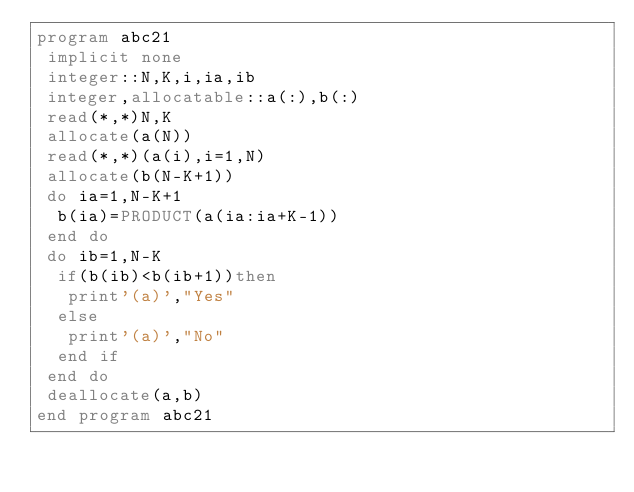<code> <loc_0><loc_0><loc_500><loc_500><_FORTRAN_>program abc21
 implicit none
 integer::N,K,i,ia,ib
 integer,allocatable::a(:),b(:)
 read(*,*)N,K
 allocate(a(N))
 read(*,*)(a(i),i=1,N)
 allocate(b(N-K+1))
 do ia=1,N-K+1
  b(ia)=PRODUCT(a(ia:ia+K-1))
 end do
 do ib=1,N-K
  if(b(ib)<b(ib+1))then
   print'(a)',"Yes"
  else
   print'(a)',"No"
  end if
 end do
 deallocate(a,b)
end program abc21</code> 